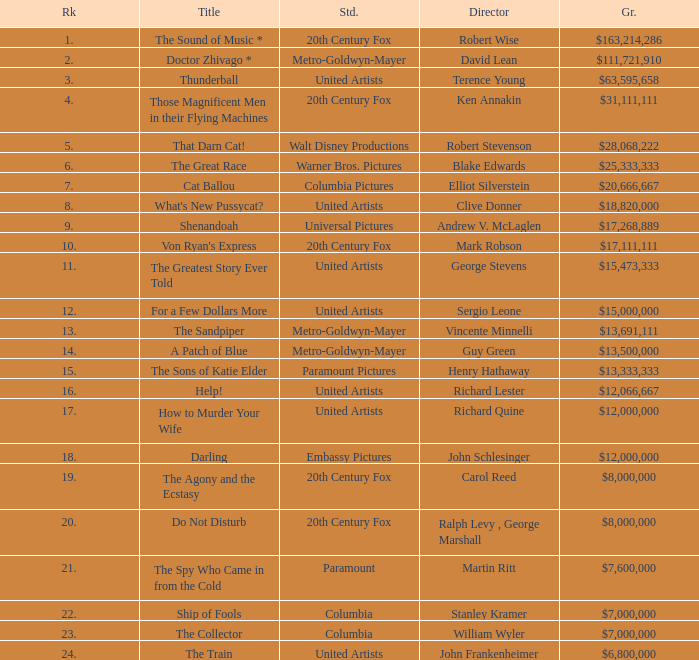In movies directed by henry hathaway, which rank is considered the highest? 15.0. 